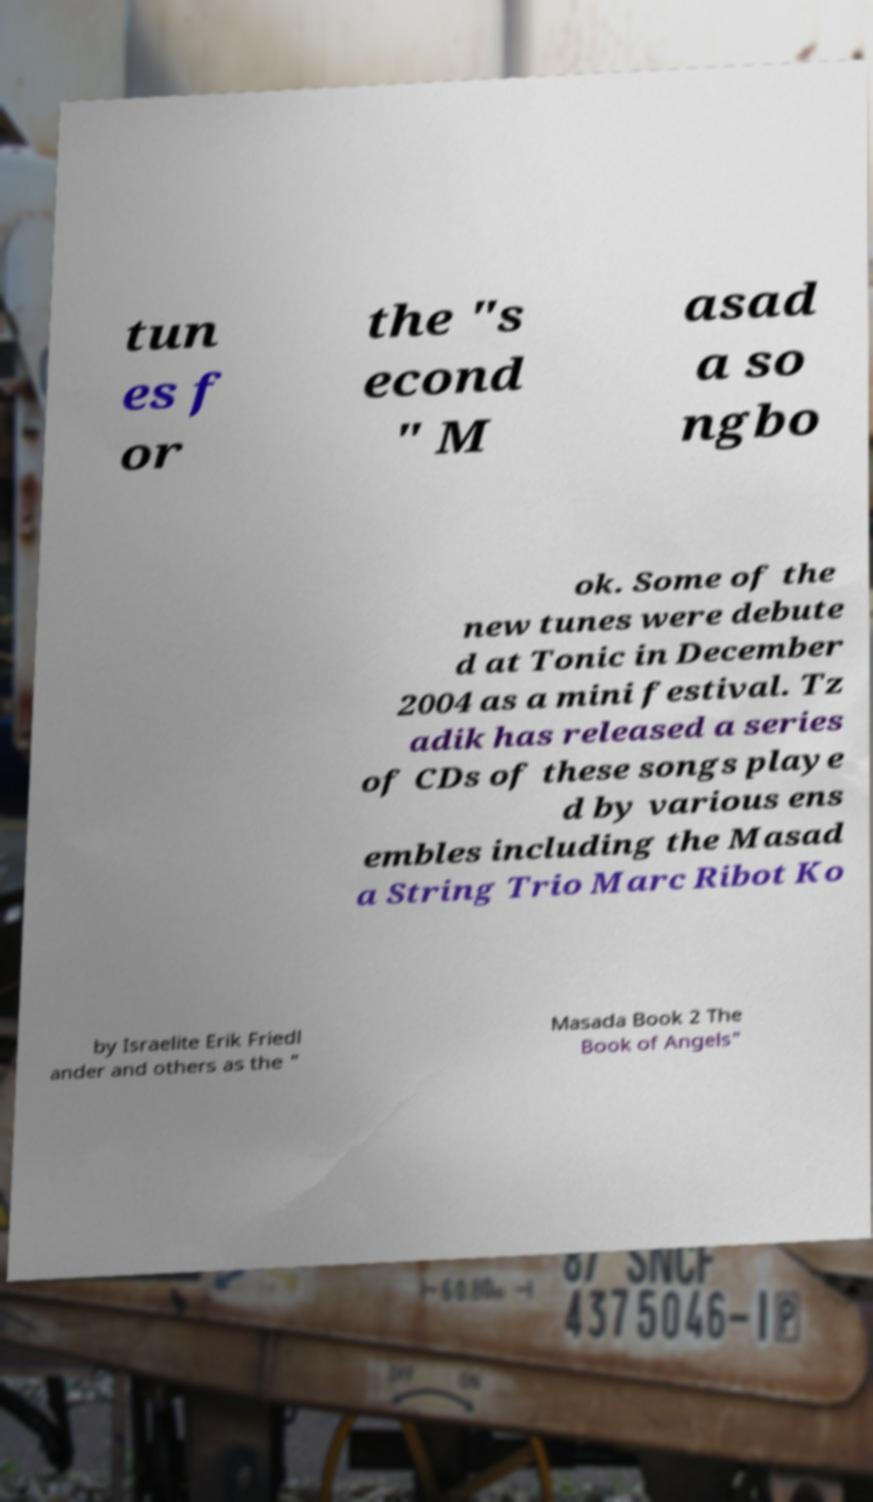Please identify and transcribe the text found in this image. tun es f or the "s econd " M asad a so ngbo ok. Some of the new tunes were debute d at Tonic in December 2004 as a mini festival. Tz adik has released a series of CDs of these songs playe d by various ens embles including the Masad a String Trio Marc Ribot Ko by Israelite Erik Friedl ander and others as the " Masada Book 2 The Book of Angels" 